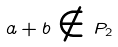Convert formula to latex. <formula><loc_0><loc_0><loc_500><loc_500>a + b \notin P _ { 2 }</formula> 